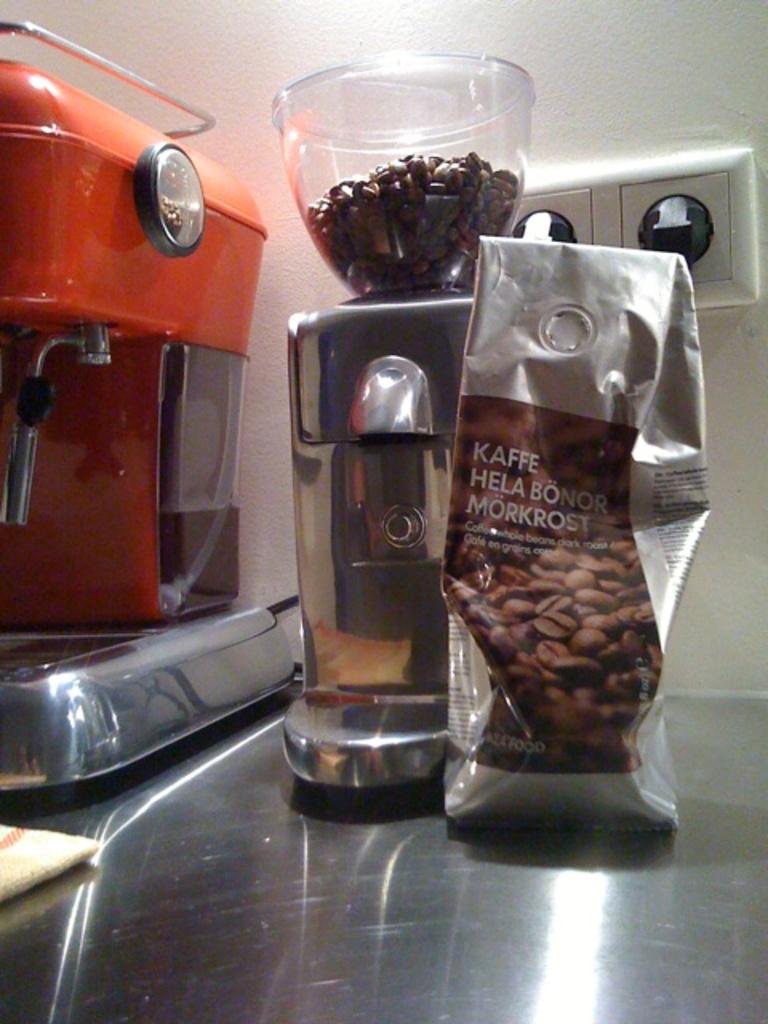What is in the bag on the table here?
Keep it short and to the point. Coffee. What is the last word in large text on the coffee bag?
Offer a very short reply. Morkrost. 